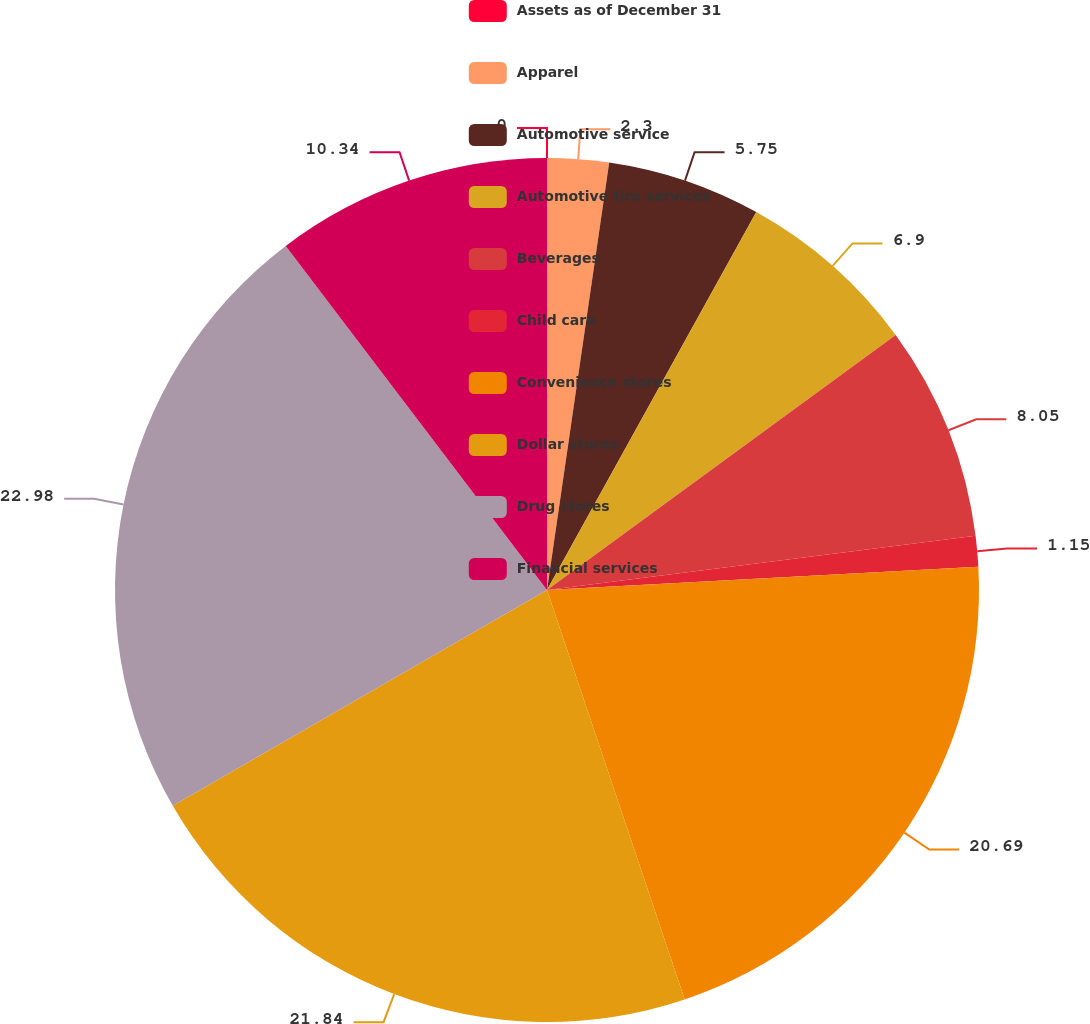Convert chart to OTSL. <chart><loc_0><loc_0><loc_500><loc_500><pie_chart><fcel>Assets as of December 31<fcel>Apparel<fcel>Automotive service<fcel>Automotive tire services<fcel>Beverages<fcel>Child care<fcel>Convenience stores<fcel>Dollar stores<fcel>Drug stores<fcel>Financial services<nl><fcel>0.0%<fcel>2.3%<fcel>5.75%<fcel>6.9%<fcel>8.05%<fcel>1.15%<fcel>20.69%<fcel>21.84%<fcel>22.99%<fcel>10.34%<nl></chart> 